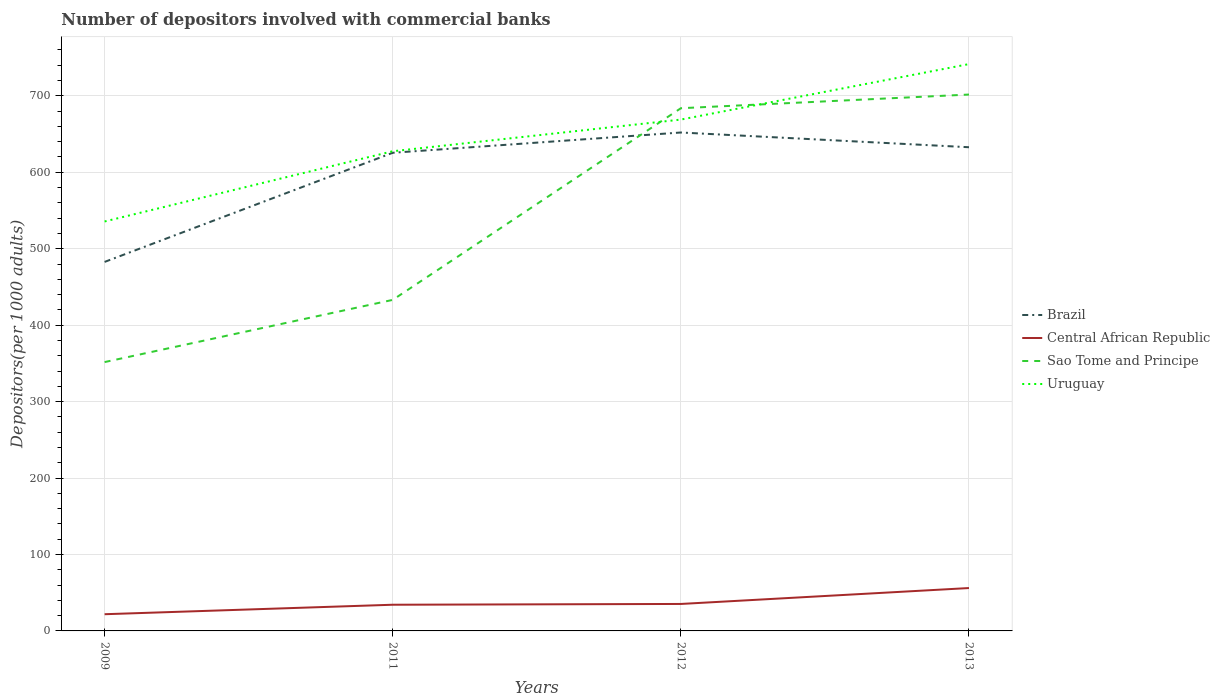Does the line corresponding to Sao Tome and Principe intersect with the line corresponding to Brazil?
Your response must be concise. Yes. Across all years, what is the maximum number of depositors involved with commercial banks in Uruguay?
Give a very brief answer. 535.65. What is the total number of depositors involved with commercial banks in Uruguay in the graph?
Your answer should be compact. -205.9. What is the difference between the highest and the second highest number of depositors involved with commercial banks in Sao Tome and Principe?
Provide a short and direct response. 349.99. What is the difference between two consecutive major ticks on the Y-axis?
Offer a very short reply. 100. Does the graph contain grids?
Ensure brevity in your answer.  Yes. Where does the legend appear in the graph?
Ensure brevity in your answer.  Center right. What is the title of the graph?
Make the answer very short. Number of depositors involved with commercial banks. Does "Puerto Rico" appear as one of the legend labels in the graph?
Your answer should be very brief. No. What is the label or title of the X-axis?
Your answer should be very brief. Years. What is the label or title of the Y-axis?
Offer a terse response. Depositors(per 1000 adults). What is the Depositors(per 1000 adults) in Brazil in 2009?
Provide a succinct answer. 482.74. What is the Depositors(per 1000 adults) of Central African Republic in 2009?
Provide a short and direct response. 21.85. What is the Depositors(per 1000 adults) of Sao Tome and Principe in 2009?
Offer a very short reply. 351.71. What is the Depositors(per 1000 adults) of Uruguay in 2009?
Offer a very short reply. 535.65. What is the Depositors(per 1000 adults) in Brazil in 2011?
Keep it short and to the point. 625.53. What is the Depositors(per 1000 adults) in Central African Republic in 2011?
Offer a very short reply. 34.26. What is the Depositors(per 1000 adults) of Sao Tome and Principe in 2011?
Ensure brevity in your answer.  433.08. What is the Depositors(per 1000 adults) of Uruguay in 2011?
Your answer should be very brief. 627.53. What is the Depositors(per 1000 adults) of Brazil in 2012?
Keep it short and to the point. 652.04. What is the Depositors(per 1000 adults) of Central African Republic in 2012?
Provide a succinct answer. 35.28. What is the Depositors(per 1000 adults) of Sao Tome and Principe in 2012?
Your answer should be compact. 683.81. What is the Depositors(per 1000 adults) of Uruguay in 2012?
Give a very brief answer. 668.96. What is the Depositors(per 1000 adults) of Brazil in 2013?
Make the answer very short. 632.77. What is the Depositors(per 1000 adults) of Central African Republic in 2013?
Ensure brevity in your answer.  56.1. What is the Depositors(per 1000 adults) in Sao Tome and Principe in 2013?
Give a very brief answer. 701.7. What is the Depositors(per 1000 adults) of Uruguay in 2013?
Your answer should be very brief. 741.55. Across all years, what is the maximum Depositors(per 1000 adults) in Brazil?
Your answer should be very brief. 652.04. Across all years, what is the maximum Depositors(per 1000 adults) of Central African Republic?
Your answer should be very brief. 56.1. Across all years, what is the maximum Depositors(per 1000 adults) of Sao Tome and Principe?
Offer a very short reply. 701.7. Across all years, what is the maximum Depositors(per 1000 adults) of Uruguay?
Offer a terse response. 741.55. Across all years, what is the minimum Depositors(per 1000 adults) in Brazil?
Give a very brief answer. 482.74. Across all years, what is the minimum Depositors(per 1000 adults) of Central African Republic?
Offer a terse response. 21.85. Across all years, what is the minimum Depositors(per 1000 adults) of Sao Tome and Principe?
Make the answer very short. 351.71. Across all years, what is the minimum Depositors(per 1000 adults) of Uruguay?
Offer a very short reply. 535.65. What is the total Depositors(per 1000 adults) in Brazil in the graph?
Ensure brevity in your answer.  2393.07. What is the total Depositors(per 1000 adults) of Central African Republic in the graph?
Give a very brief answer. 147.48. What is the total Depositors(per 1000 adults) of Sao Tome and Principe in the graph?
Keep it short and to the point. 2170.3. What is the total Depositors(per 1000 adults) of Uruguay in the graph?
Keep it short and to the point. 2573.69. What is the difference between the Depositors(per 1000 adults) of Brazil in 2009 and that in 2011?
Make the answer very short. -142.79. What is the difference between the Depositors(per 1000 adults) in Central African Republic in 2009 and that in 2011?
Your answer should be compact. -12.4. What is the difference between the Depositors(per 1000 adults) in Sao Tome and Principe in 2009 and that in 2011?
Ensure brevity in your answer.  -81.37. What is the difference between the Depositors(per 1000 adults) in Uruguay in 2009 and that in 2011?
Provide a short and direct response. -91.88. What is the difference between the Depositors(per 1000 adults) of Brazil in 2009 and that in 2012?
Provide a succinct answer. -169.3. What is the difference between the Depositors(per 1000 adults) in Central African Republic in 2009 and that in 2012?
Give a very brief answer. -13.43. What is the difference between the Depositors(per 1000 adults) of Sao Tome and Principe in 2009 and that in 2012?
Make the answer very short. -332.1. What is the difference between the Depositors(per 1000 adults) in Uruguay in 2009 and that in 2012?
Give a very brief answer. -133.31. What is the difference between the Depositors(per 1000 adults) of Brazil in 2009 and that in 2013?
Provide a succinct answer. -150.03. What is the difference between the Depositors(per 1000 adults) of Central African Republic in 2009 and that in 2013?
Provide a succinct answer. -34.25. What is the difference between the Depositors(per 1000 adults) of Sao Tome and Principe in 2009 and that in 2013?
Your response must be concise. -349.99. What is the difference between the Depositors(per 1000 adults) of Uruguay in 2009 and that in 2013?
Provide a short and direct response. -205.9. What is the difference between the Depositors(per 1000 adults) of Brazil in 2011 and that in 2012?
Provide a short and direct response. -26.51. What is the difference between the Depositors(per 1000 adults) in Central African Republic in 2011 and that in 2012?
Make the answer very short. -1.02. What is the difference between the Depositors(per 1000 adults) of Sao Tome and Principe in 2011 and that in 2012?
Your response must be concise. -250.73. What is the difference between the Depositors(per 1000 adults) of Uruguay in 2011 and that in 2012?
Ensure brevity in your answer.  -41.43. What is the difference between the Depositors(per 1000 adults) of Brazil in 2011 and that in 2013?
Give a very brief answer. -7.23. What is the difference between the Depositors(per 1000 adults) of Central African Republic in 2011 and that in 2013?
Your answer should be very brief. -21.84. What is the difference between the Depositors(per 1000 adults) in Sao Tome and Principe in 2011 and that in 2013?
Make the answer very short. -268.62. What is the difference between the Depositors(per 1000 adults) of Uruguay in 2011 and that in 2013?
Provide a short and direct response. -114.02. What is the difference between the Depositors(per 1000 adults) of Brazil in 2012 and that in 2013?
Your answer should be compact. 19.27. What is the difference between the Depositors(per 1000 adults) in Central African Republic in 2012 and that in 2013?
Provide a short and direct response. -20.82. What is the difference between the Depositors(per 1000 adults) in Sao Tome and Principe in 2012 and that in 2013?
Your answer should be very brief. -17.89. What is the difference between the Depositors(per 1000 adults) of Uruguay in 2012 and that in 2013?
Give a very brief answer. -72.59. What is the difference between the Depositors(per 1000 adults) of Brazil in 2009 and the Depositors(per 1000 adults) of Central African Republic in 2011?
Provide a short and direct response. 448.48. What is the difference between the Depositors(per 1000 adults) in Brazil in 2009 and the Depositors(per 1000 adults) in Sao Tome and Principe in 2011?
Keep it short and to the point. 49.66. What is the difference between the Depositors(per 1000 adults) in Brazil in 2009 and the Depositors(per 1000 adults) in Uruguay in 2011?
Offer a terse response. -144.79. What is the difference between the Depositors(per 1000 adults) of Central African Republic in 2009 and the Depositors(per 1000 adults) of Sao Tome and Principe in 2011?
Make the answer very short. -411.23. What is the difference between the Depositors(per 1000 adults) of Central African Republic in 2009 and the Depositors(per 1000 adults) of Uruguay in 2011?
Give a very brief answer. -605.68. What is the difference between the Depositors(per 1000 adults) of Sao Tome and Principe in 2009 and the Depositors(per 1000 adults) of Uruguay in 2011?
Your answer should be compact. -275.82. What is the difference between the Depositors(per 1000 adults) in Brazil in 2009 and the Depositors(per 1000 adults) in Central African Republic in 2012?
Provide a succinct answer. 447.46. What is the difference between the Depositors(per 1000 adults) in Brazil in 2009 and the Depositors(per 1000 adults) in Sao Tome and Principe in 2012?
Your response must be concise. -201.07. What is the difference between the Depositors(per 1000 adults) of Brazil in 2009 and the Depositors(per 1000 adults) of Uruguay in 2012?
Ensure brevity in your answer.  -186.22. What is the difference between the Depositors(per 1000 adults) of Central African Republic in 2009 and the Depositors(per 1000 adults) of Sao Tome and Principe in 2012?
Provide a short and direct response. -661.96. What is the difference between the Depositors(per 1000 adults) in Central African Republic in 2009 and the Depositors(per 1000 adults) in Uruguay in 2012?
Offer a terse response. -647.11. What is the difference between the Depositors(per 1000 adults) of Sao Tome and Principe in 2009 and the Depositors(per 1000 adults) of Uruguay in 2012?
Provide a short and direct response. -317.25. What is the difference between the Depositors(per 1000 adults) of Brazil in 2009 and the Depositors(per 1000 adults) of Central African Republic in 2013?
Give a very brief answer. 426.64. What is the difference between the Depositors(per 1000 adults) in Brazil in 2009 and the Depositors(per 1000 adults) in Sao Tome and Principe in 2013?
Your answer should be compact. -218.96. What is the difference between the Depositors(per 1000 adults) of Brazil in 2009 and the Depositors(per 1000 adults) of Uruguay in 2013?
Ensure brevity in your answer.  -258.81. What is the difference between the Depositors(per 1000 adults) in Central African Republic in 2009 and the Depositors(per 1000 adults) in Sao Tome and Principe in 2013?
Offer a terse response. -679.85. What is the difference between the Depositors(per 1000 adults) of Central African Republic in 2009 and the Depositors(per 1000 adults) of Uruguay in 2013?
Your answer should be very brief. -719.7. What is the difference between the Depositors(per 1000 adults) of Sao Tome and Principe in 2009 and the Depositors(per 1000 adults) of Uruguay in 2013?
Provide a succinct answer. -389.84. What is the difference between the Depositors(per 1000 adults) in Brazil in 2011 and the Depositors(per 1000 adults) in Central African Republic in 2012?
Provide a succinct answer. 590.25. What is the difference between the Depositors(per 1000 adults) of Brazil in 2011 and the Depositors(per 1000 adults) of Sao Tome and Principe in 2012?
Keep it short and to the point. -58.28. What is the difference between the Depositors(per 1000 adults) in Brazil in 2011 and the Depositors(per 1000 adults) in Uruguay in 2012?
Provide a succinct answer. -43.43. What is the difference between the Depositors(per 1000 adults) in Central African Republic in 2011 and the Depositors(per 1000 adults) in Sao Tome and Principe in 2012?
Your answer should be very brief. -649.56. What is the difference between the Depositors(per 1000 adults) in Central African Republic in 2011 and the Depositors(per 1000 adults) in Uruguay in 2012?
Provide a short and direct response. -634.71. What is the difference between the Depositors(per 1000 adults) in Sao Tome and Principe in 2011 and the Depositors(per 1000 adults) in Uruguay in 2012?
Provide a short and direct response. -235.88. What is the difference between the Depositors(per 1000 adults) of Brazil in 2011 and the Depositors(per 1000 adults) of Central African Republic in 2013?
Keep it short and to the point. 569.43. What is the difference between the Depositors(per 1000 adults) in Brazil in 2011 and the Depositors(per 1000 adults) in Sao Tome and Principe in 2013?
Give a very brief answer. -76.17. What is the difference between the Depositors(per 1000 adults) of Brazil in 2011 and the Depositors(per 1000 adults) of Uruguay in 2013?
Give a very brief answer. -116.02. What is the difference between the Depositors(per 1000 adults) of Central African Republic in 2011 and the Depositors(per 1000 adults) of Sao Tome and Principe in 2013?
Your response must be concise. -667.44. What is the difference between the Depositors(per 1000 adults) of Central African Republic in 2011 and the Depositors(per 1000 adults) of Uruguay in 2013?
Your answer should be very brief. -707.29. What is the difference between the Depositors(per 1000 adults) in Sao Tome and Principe in 2011 and the Depositors(per 1000 adults) in Uruguay in 2013?
Your answer should be compact. -308.47. What is the difference between the Depositors(per 1000 adults) in Brazil in 2012 and the Depositors(per 1000 adults) in Central African Republic in 2013?
Your response must be concise. 595.94. What is the difference between the Depositors(per 1000 adults) of Brazil in 2012 and the Depositors(per 1000 adults) of Sao Tome and Principe in 2013?
Offer a terse response. -49.66. What is the difference between the Depositors(per 1000 adults) in Brazil in 2012 and the Depositors(per 1000 adults) in Uruguay in 2013?
Keep it short and to the point. -89.51. What is the difference between the Depositors(per 1000 adults) of Central African Republic in 2012 and the Depositors(per 1000 adults) of Sao Tome and Principe in 2013?
Your answer should be compact. -666.42. What is the difference between the Depositors(per 1000 adults) of Central African Republic in 2012 and the Depositors(per 1000 adults) of Uruguay in 2013?
Offer a very short reply. -706.27. What is the difference between the Depositors(per 1000 adults) in Sao Tome and Principe in 2012 and the Depositors(per 1000 adults) in Uruguay in 2013?
Offer a terse response. -57.74. What is the average Depositors(per 1000 adults) in Brazil per year?
Your response must be concise. 598.27. What is the average Depositors(per 1000 adults) of Central African Republic per year?
Provide a short and direct response. 36.87. What is the average Depositors(per 1000 adults) of Sao Tome and Principe per year?
Your answer should be compact. 542.58. What is the average Depositors(per 1000 adults) in Uruguay per year?
Provide a short and direct response. 643.42. In the year 2009, what is the difference between the Depositors(per 1000 adults) in Brazil and Depositors(per 1000 adults) in Central African Republic?
Keep it short and to the point. 460.89. In the year 2009, what is the difference between the Depositors(per 1000 adults) of Brazil and Depositors(per 1000 adults) of Sao Tome and Principe?
Offer a very short reply. 131.03. In the year 2009, what is the difference between the Depositors(per 1000 adults) of Brazil and Depositors(per 1000 adults) of Uruguay?
Give a very brief answer. -52.91. In the year 2009, what is the difference between the Depositors(per 1000 adults) of Central African Republic and Depositors(per 1000 adults) of Sao Tome and Principe?
Keep it short and to the point. -329.86. In the year 2009, what is the difference between the Depositors(per 1000 adults) of Central African Republic and Depositors(per 1000 adults) of Uruguay?
Provide a short and direct response. -513.8. In the year 2009, what is the difference between the Depositors(per 1000 adults) in Sao Tome and Principe and Depositors(per 1000 adults) in Uruguay?
Keep it short and to the point. -183.94. In the year 2011, what is the difference between the Depositors(per 1000 adults) in Brazil and Depositors(per 1000 adults) in Central African Republic?
Keep it short and to the point. 591.28. In the year 2011, what is the difference between the Depositors(per 1000 adults) of Brazil and Depositors(per 1000 adults) of Sao Tome and Principe?
Provide a short and direct response. 192.45. In the year 2011, what is the difference between the Depositors(per 1000 adults) of Brazil and Depositors(per 1000 adults) of Uruguay?
Keep it short and to the point. -2. In the year 2011, what is the difference between the Depositors(per 1000 adults) of Central African Republic and Depositors(per 1000 adults) of Sao Tome and Principe?
Offer a very short reply. -398.83. In the year 2011, what is the difference between the Depositors(per 1000 adults) in Central African Republic and Depositors(per 1000 adults) in Uruguay?
Provide a short and direct response. -593.28. In the year 2011, what is the difference between the Depositors(per 1000 adults) in Sao Tome and Principe and Depositors(per 1000 adults) in Uruguay?
Give a very brief answer. -194.45. In the year 2012, what is the difference between the Depositors(per 1000 adults) in Brazil and Depositors(per 1000 adults) in Central African Republic?
Provide a short and direct response. 616.76. In the year 2012, what is the difference between the Depositors(per 1000 adults) in Brazil and Depositors(per 1000 adults) in Sao Tome and Principe?
Your answer should be very brief. -31.77. In the year 2012, what is the difference between the Depositors(per 1000 adults) of Brazil and Depositors(per 1000 adults) of Uruguay?
Keep it short and to the point. -16.92. In the year 2012, what is the difference between the Depositors(per 1000 adults) of Central African Republic and Depositors(per 1000 adults) of Sao Tome and Principe?
Provide a short and direct response. -648.53. In the year 2012, what is the difference between the Depositors(per 1000 adults) in Central African Republic and Depositors(per 1000 adults) in Uruguay?
Keep it short and to the point. -633.68. In the year 2012, what is the difference between the Depositors(per 1000 adults) of Sao Tome and Principe and Depositors(per 1000 adults) of Uruguay?
Ensure brevity in your answer.  14.85. In the year 2013, what is the difference between the Depositors(per 1000 adults) of Brazil and Depositors(per 1000 adults) of Central African Republic?
Provide a succinct answer. 576.67. In the year 2013, what is the difference between the Depositors(per 1000 adults) in Brazil and Depositors(per 1000 adults) in Sao Tome and Principe?
Your answer should be compact. -68.93. In the year 2013, what is the difference between the Depositors(per 1000 adults) of Brazil and Depositors(per 1000 adults) of Uruguay?
Provide a succinct answer. -108.78. In the year 2013, what is the difference between the Depositors(per 1000 adults) in Central African Republic and Depositors(per 1000 adults) in Sao Tome and Principe?
Provide a short and direct response. -645.6. In the year 2013, what is the difference between the Depositors(per 1000 adults) of Central African Republic and Depositors(per 1000 adults) of Uruguay?
Your answer should be very brief. -685.45. In the year 2013, what is the difference between the Depositors(per 1000 adults) of Sao Tome and Principe and Depositors(per 1000 adults) of Uruguay?
Ensure brevity in your answer.  -39.85. What is the ratio of the Depositors(per 1000 adults) of Brazil in 2009 to that in 2011?
Your answer should be very brief. 0.77. What is the ratio of the Depositors(per 1000 adults) of Central African Republic in 2009 to that in 2011?
Keep it short and to the point. 0.64. What is the ratio of the Depositors(per 1000 adults) of Sao Tome and Principe in 2009 to that in 2011?
Your response must be concise. 0.81. What is the ratio of the Depositors(per 1000 adults) of Uruguay in 2009 to that in 2011?
Give a very brief answer. 0.85. What is the ratio of the Depositors(per 1000 adults) in Brazil in 2009 to that in 2012?
Your response must be concise. 0.74. What is the ratio of the Depositors(per 1000 adults) in Central African Republic in 2009 to that in 2012?
Offer a very short reply. 0.62. What is the ratio of the Depositors(per 1000 adults) of Sao Tome and Principe in 2009 to that in 2012?
Your answer should be very brief. 0.51. What is the ratio of the Depositors(per 1000 adults) of Uruguay in 2009 to that in 2012?
Your response must be concise. 0.8. What is the ratio of the Depositors(per 1000 adults) in Brazil in 2009 to that in 2013?
Provide a succinct answer. 0.76. What is the ratio of the Depositors(per 1000 adults) of Central African Republic in 2009 to that in 2013?
Give a very brief answer. 0.39. What is the ratio of the Depositors(per 1000 adults) in Sao Tome and Principe in 2009 to that in 2013?
Provide a succinct answer. 0.5. What is the ratio of the Depositors(per 1000 adults) of Uruguay in 2009 to that in 2013?
Provide a short and direct response. 0.72. What is the ratio of the Depositors(per 1000 adults) of Brazil in 2011 to that in 2012?
Make the answer very short. 0.96. What is the ratio of the Depositors(per 1000 adults) of Central African Republic in 2011 to that in 2012?
Keep it short and to the point. 0.97. What is the ratio of the Depositors(per 1000 adults) of Sao Tome and Principe in 2011 to that in 2012?
Make the answer very short. 0.63. What is the ratio of the Depositors(per 1000 adults) in Uruguay in 2011 to that in 2012?
Make the answer very short. 0.94. What is the ratio of the Depositors(per 1000 adults) of Brazil in 2011 to that in 2013?
Your answer should be very brief. 0.99. What is the ratio of the Depositors(per 1000 adults) of Central African Republic in 2011 to that in 2013?
Ensure brevity in your answer.  0.61. What is the ratio of the Depositors(per 1000 adults) in Sao Tome and Principe in 2011 to that in 2013?
Provide a succinct answer. 0.62. What is the ratio of the Depositors(per 1000 adults) of Uruguay in 2011 to that in 2013?
Your response must be concise. 0.85. What is the ratio of the Depositors(per 1000 adults) of Brazil in 2012 to that in 2013?
Provide a succinct answer. 1.03. What is the ratio of the Depositors(per 1000 adults) in Central African Republic in 2012 to that in 2013?
Keep it short and to the point. 0.63. What is the ratio of the Depositors(per 1000 adults) of Sao Tome and Principe in 2012 to that in 2013?
Make the answer very short. 0.97. What is the ratio of the Depositors(per 1000 adults) of Uruguay in 2012 to that in 2013?
Keep it short and to the point. 0.9. What is the difference between the highest and the second highest Depositors(per 1000 adults) of Brazil?
Your answer should be compact. 19.27. What is the difference between the highest and the second highest Depositors(per 1000 adults) in Central African Republic?
Keep it short and to the point. 20.82. What is the difference between the highest and the second highest Depositors(per 1000 adults) of Sao Tome and Principe?
Provide a succinct answer. 17.89. What is the difference between the highest and the second highest Depositors(per 1000 adults) in Uruguay?
Your answer should be very brief. 72.59. What is the difference between the highest and the lowest Depositors(per 1000 adults) in Brazil?
Offer a very short reply. 169.3. What is the difference between the highest and the lowest Depositors(per 1000 adults) in Central African Republic?
Give a very brief answer. 34.25. What is the difference between the highest and the lowest Depositors(per 1000 adults) in Sao Tome and Principe?
Provide a succinct answer. 349.99. What is the difference between the highest and the lowest Depositors(per 1000 adults) of Uruguay?
Give a very brief answer. 205.9. 